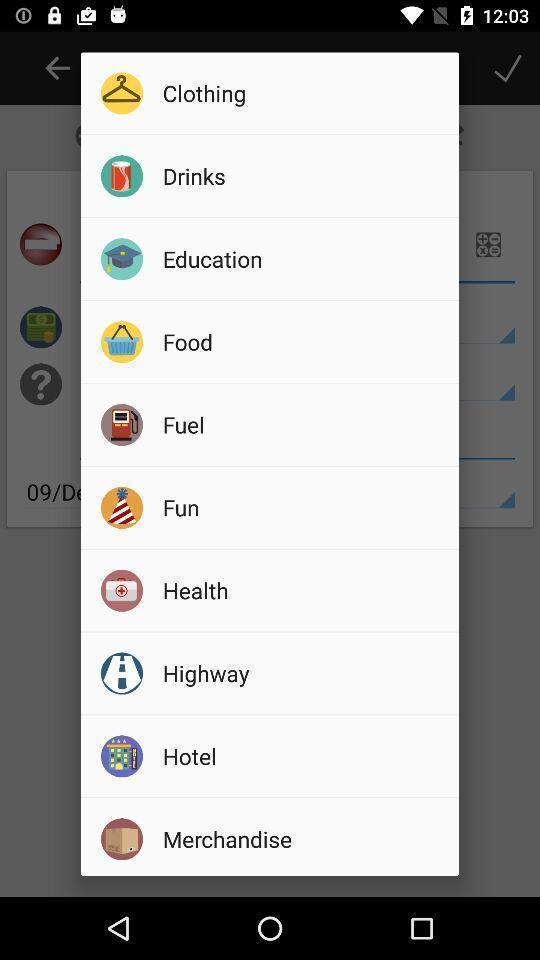Summarize the information in this screenshot. Popup of different categories of tabs in application. 